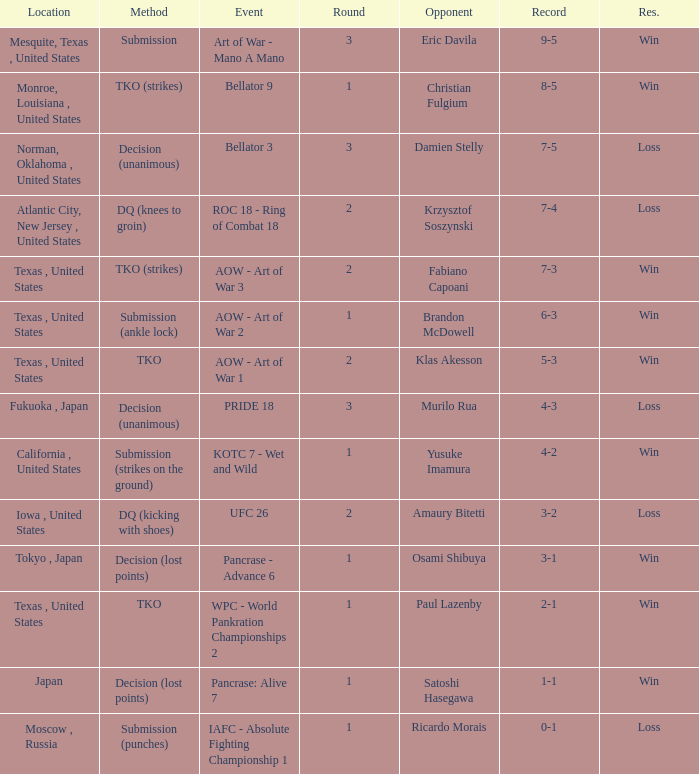What is the average round against opponent Klas Akesson? 2.0. 